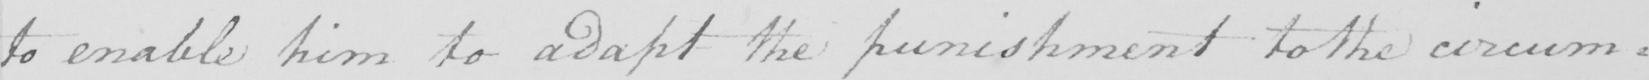Transcribe the text shown in this historical manuscript line. to enable him to adapt the punishment to the circum : 